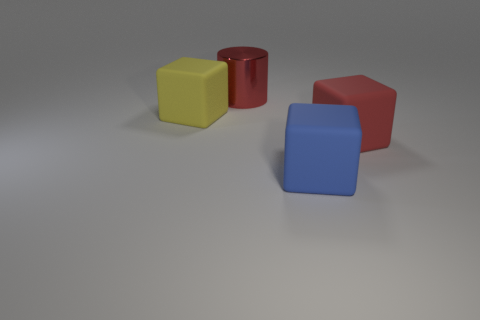What is the size of the cube that is the same color as the big cylinder?
Offer a very short reply. Large. There is a red block that is made of the same material as the yellow object; what size is it?
Provide a succinct answer. Large. How big is the blue object?
Your answer should be compact. Large. The red shiny object has what shape?
Keep it short and to the point. Cylinder. Do the large block that is right of the large blue matte thing and the large cylinder have the same color?
Offer a very short reply. Yes. There is a yellow rubber thing that is the same shape as the red matte thing; what size is it?
Offer a very short reply. Large. Is there any other thing that is made of the same material as the large blue object?
Provide a short and direct response. Yes. There is a big red object in front of the large object that is behind the large yellow cube; is there a blue thing that is to the left of it?
Your response must be concise. Yes. There is a object that is left of the big red shiny object; what is it made of?
Your answer should be very brief. Rubber. How many big objects are either red shiny cylinders or yellow matte blocks?
Make the answer very short. 2. 